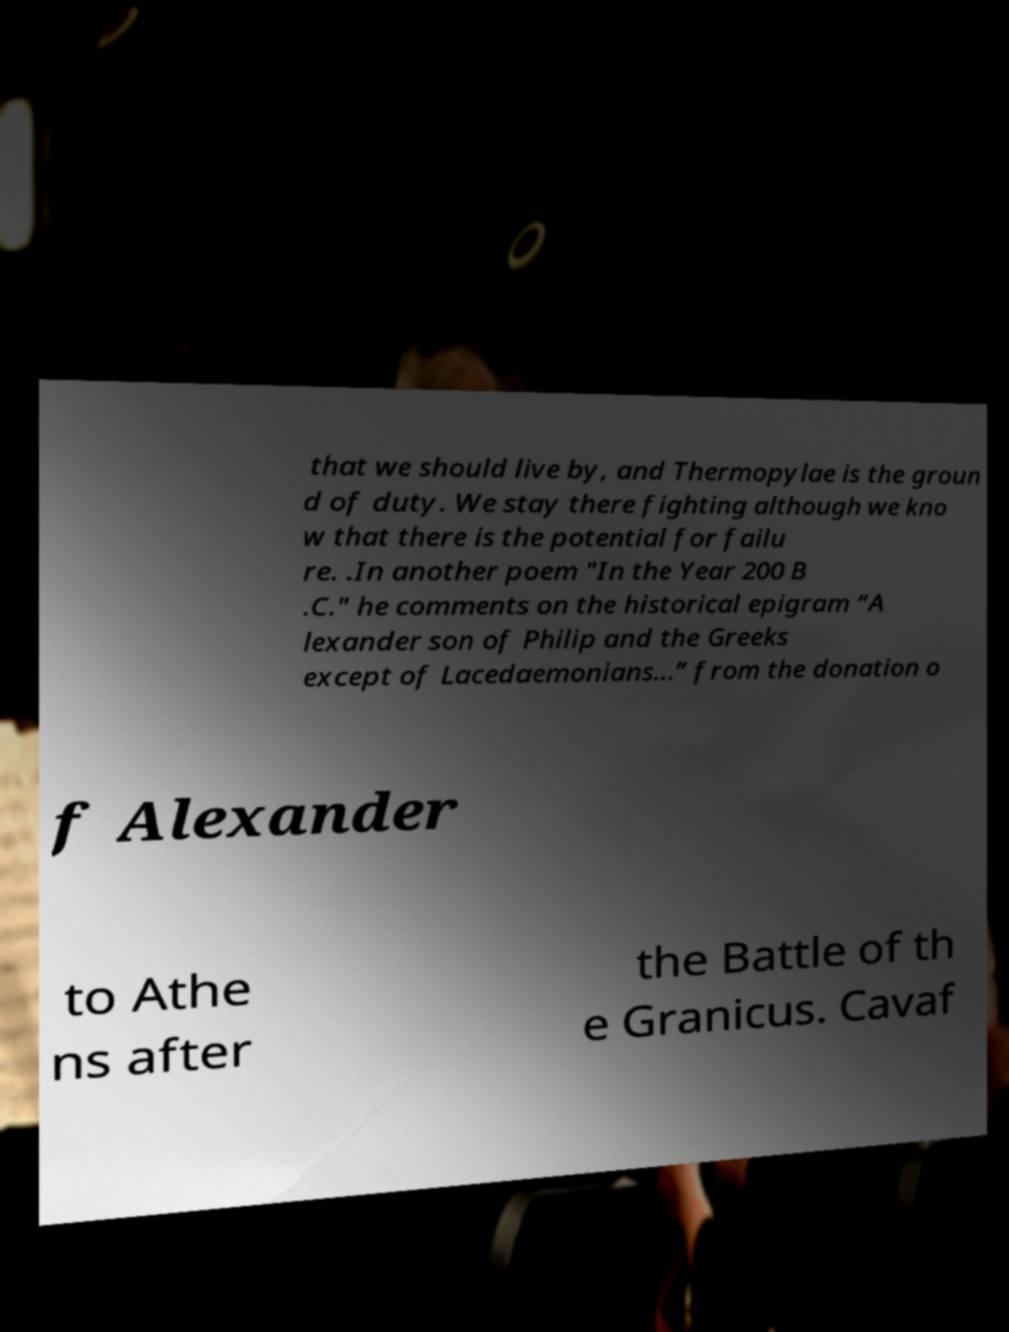Could you extract and type out the text from this image? that we should live by, and Thermopylae is the groun d of duty. We stay there fighting although we kno w that there is the potential for failu re. .In another poem "In the Year 200 B .C." he comments on the historical epigram “A lexander son of Philip and the Greeks except of Lacedaemonians...” from the donation o f Alexander to Athe ns after the Battle of th e Granicus. Cavaf 